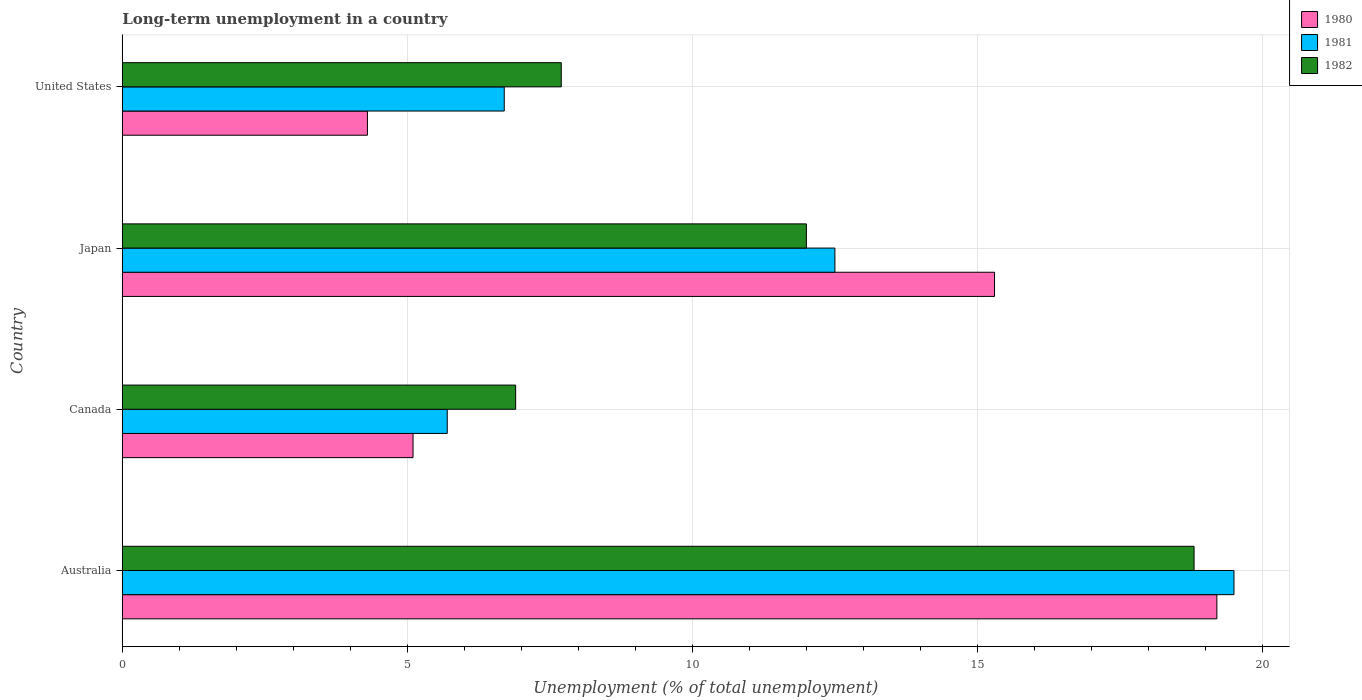Are the number of bars per tick equal to the number of legend labels?
Your answer should be compact. Yes. Are the number of bars on each tick of the Y-axis equal?
Provide a short and direct response. Yes. How many bars are there on the 4th tick from the top?
Your answer should be very brief. 3. What is the label of the 4th group of bars from the top?
Give a very brief answer. Australia. What is the percentage of long-term unemployed population in 1981 in United States?
Offer a very short reply. 6.7. Across all countries, what is the maximum percentage of long-term unemployed population in 1981?
Ensure brevity in your answer.  19.5. Across all countries, what is the minimum percentage of long-term unemployed population in 1982?
Your response must be concise. 6.9. In which country was the percentage of long-term unemployed population in 1981 maximum?
Your answer should be compact. Australia. What is the total percentage of long-term unemployed population in 1981 in the graph?
Make the answer very short. 44.4. What is the difference between the percentage of long-term unemployed population in 1982 in Canada and that in United States?
Provide a short and direct response. -0.8. What is the difference between the percentage of long-term unemployed population in 1981 in United States and the percentage of long-term unemployed population in 1982 in Australia?
Provide a succinct answer. -12.1. What is the average percentage of long-term unemployed population in 1981 per country?
Make the answer very short. 11.1. What is the difference between the percentage of long-term unemployed population in 1980 and percentage of long-term unemployed population in 1981 in Japan?
Your answer should be very brief. 2.8. In how many countries, is the percentage of long-term unemployed population in 1982 greater than 12 %?
Your answer should be compact. 1. What is the ratio of the percentage of long-term unemployed population in 1982 in Canada to that in Japan?
Your answer should be compact. 0.58. What is the difference between the highest and the lowest percentage of long-term unemployed population in 1982?
Provide a short and direct response. 11.9. In how many countries, is the percentage of long-term unemployed population in 1981 greater than the average percentage of long-term unemployed population in 1981 taken over all countries?
Ensure brevity in your answer.  2. Is the sum of the percentage of long-term unemployed population in 1982 in Australia and United States greater than the maximum percentage of long-term unemployed population in 1980 across all countries?
Your response must be concise. Yes. What does the 1st bar from the top in Japan represents?
Your answer should be compact. 1982. How many bars are there?
Provide a succinct answer. 12. How many countries are there in the graph?
Provide a succinct answer. 4. What is the difference between two consecutive major ticks on the X-axis?
Make the answer very short. 5. Does the graph contain grids?
Your answer should be compact. Yes. Where does the legend appear in the graph?
Offer a very short reply. Top right. How many legend labels are there?
Your answer should be very brief. 3. How are the legend labels stacked?
Offer a terse response. Vertical. What is the title of the graph?
Your answer should be compact. Long-term unemployment in a country. What is the label or title of the X-axis?
Keep it short and to the point. Unemployment (% of total unemployment). What is the Unemployment (% of total unemployment) of 1980 in Australia?
Ensure brevity in your answer.  19.2. What is the Unemployment (% of total unemployment) of 1982 in Australia?
Give a very brief answer. 18.8. What is the Unemployment (% of total unemployment) of 1980 in Canada?
Your answer should be compact. 5.1. What is the Unemployment (% of total unemployment) in 1981 in Canada?
Keep it short and to the point. 5.7. What is the Unemployment (% of total unemployment) of 1982 in Canada?
Offer a terse response. 6.9. What is the Unemployment (% of total unemployment) of 1980 in Japan?
Ensure brevity in your answer.  15.3. What is the Unemployment (% of total unemployment) in 1982 in Japan?
Offer a terse response. 12. What is the Unemployment (% of total unemployment) of 1980 in United States?
Your response must be concise. 4.3. What is the Unemployment (% of total unemployment) of 1981 in United States?
Ensure brevity in your answer.  6.7. What is the Unemployment (% of total unemployment) in 1982 in United States?
Offer a terse response. 7.7. Across all countries, what is the maximum Unemployment (% of total unemployment) of 1980?
Provide a succinct answer. 19.2. Across all countries, what is the maximum Unemployment (% of total unemployment) of 1982?
Offer a terse response. 18.8. Across all countries, what is the minimum Unemployment (% of total unemployment) in 1980?
Offer a very short reply. 4.3. Across all countries, what is the minimum Unemployment (% of total unemployment) of 1981?
Offer a very short reply. 5.7. Across all countries, what is the minimum Unemployment (% of total unemployment) in 1982?
Your answer should be very brief. 6.9. What is the total Unemployment (% of total unemployment) in 1980 in the graph?
Give a very brief answer. 43.9. What is the total Unemployment (% of total unemployment) of 1981 in the graph?
Ensure brevity in your answer.  44.4. What is the total Unemployment (% of total unemployment) of 1982 in the graph?
Your answer should be very brief. 45.4. What is the difference between the Unemployment (% of total unemployment) of 1981 in Australia and that in Canada?
Give a very brief answer. 13.8. What is the difference between the Unemployment (% of total unemployment) of 1982 in Australia and that in Canada?
Offer a very short reply. 11.9. What is the difference between the Unemployment (% of total unemployment) in 1981 in Australia and that in Japan?
Give a very brief answer. 7. What is the difference between the Unemployment (% of total unemployment) of 1982 in Australia and that in Japan?
Your answer should be very brief. 6.8. What is the difference between the Unemployment (% of total unemployment) of 1981 in Australia and that in United States?
Offer a terse response. 12.8. What is the difference between the Unemployment (% of total unemployment) in 1981 in Canada and that in Japan?
Ensure brevity in your answer.  -6.8. What is the difference between the Unemployment (% of total unemployment) in 1982 in Canada and that in United States?
Make the answer very short. -0.8. What is the difference between the Unemployment (% of total unemployment) in 1980 in Japan and that in United States?
Provide a succinct answer. 11. What is the difference between the Unemployment (% of total unemployment) in 1981 in Japan and that in United States?
Provide a succinct answer. 5.8. What is the difference between the Unemployment (% of total unemployment) of 1982 in Japan and that in United States?
Provide a short and direct response. 4.3. What is the difference between the Unemployment (% of total unemployment) of 1980 in Australia and the Unemployment (% of total unemployment) of 1982 in Canada?
Your response must be concise. 12.3. What is the difference between the Unemployment (% of total unemployment) of 1981 in Australia and the Unemployment (% of total unemployment) of 1982 in United States?
Keep it short and to the point. 11.8. What is the difference between the Unemployment (% of total unemployment) in 1981 in Canada and the Unemployment (% of total unemployment) in 1982 in Japan?
Offer a terse response. -6.3. What is the difference between the Unemployment (% of total unemployment) in 1980 in Canada and the Unemployment (% of total unemployment) in 1982 in United States?
Ensure brevity in your answer.  -2.6. What is the difference between the Unemployment (% of total unemployment) in 1980 in Japan and the Unemployment (% of total unemployment) in 1982 in United States?
Your answer should be compact. 7.6. What is the average Unemployment (% of total unemployment) in 1980 per country?
Your answer should be compact. 10.97. What is the average Unemployment (% of total unemployment) of 1981 per country?
Provide a succinct answer. 11.1. What is the average Unemployment (% of total unemployment) in 1982 per country?
Give a very brief answer. 11.35. What is the difference between the Unemployment (% of total unemployment) in 1980 and Unemployment (% of total unemployment) in 1982 in Australia?
Your response must be concise. 0.4. What is the difference between the Unemployment (% of total unemployment) of 1981 and Unemployment (% of total unemployment) of 1982 in Australia?
Your answer should be very brief. 0.7. What is the difference between the Unemployment (% of total unemployment) in 1980 and Unemployment (% of total unemployment) in 1981 in Canada?
Ensure brevity in your answer.  -0.6. What is the difference between the Unemployment (% of total unemployment) in 1980 and Unemployment (% of total unemployment) in 1982 in Canada?
Ensure brevity in your answer.  -1.8. What is the difference between the Unemployment (% of total unemployment) in 1981 and Unemployment (% of total unemployment) in 1982 in Canada?
Offer a terse response. -1.2. What is the ratio of the Unemployment (% of total unemployment) in 1980 in Australia to that in Canada?
Keep it short and to the point. 3.76. What is the ratio of the Unemployment (% of total unemployment) of 1981 in Australia to that in Canada?
Make the answer very short. 3.42. What is the ratio of the Unemployment (% of total unemployment) in 1982 in Australia to that in Canada?
Provide a succinct answer. 2.72. What is the ratio of the Unemployment (% of total unemployment) of 1980 in Australia to that in Japan?
Provide a short and direct response. 1.25. What is the ratio of the Unemployment (% of total unemployment) of 1981 in Australia to that in Japan?
Your response must be concise. 1.56. What is the ratio of the Unemployment (% of total unemployment) in 1982 in Australia to that in Japan?
Your response must be concise. 1.57. What is the ratio of the Unemployment (% of total unemployment) of 1980 in Australia to that in United States?
Your answer should be compact. 4.47. What is the ratio of the Unemployment (% of total unemployment) in 1981 in Australia to that in United States?
Provide a short and direct response. 2.91. What is the ratio of the Unemployment (% of total unemployment) of 1982 in Australia to that in United States?
Keep it short and to the point. 2.44. What is the ratio of the Unemployment (% of total unemployment) in 1980 in Canada to that in Japan?
Ensure brevity in your answer.  0.33. What is the ratio of the Unemployment (% of total unemployment) of 1981 in Canada to that in Japan?
Give a very brief answer. 0.46. What is the ratio of the Unemployment (% of total unemployment) of 1982 in Canada to that in Japan?
Offer a very short reply. 0.57. What is the ratio of the Unemployment (% of total unemployment) of 1980 in Canada to that in United States?
Provide a short and direct response. 1.19. What is the ratio of the Unemployment (% of total unemployment) in 1981 in Canada to that in United States?
Provide a succinct answer. 0.85. What is the ratio of the Unemployment (% of total unemployment) in 1982 in Canada to that in United States?
Make the answer very short. 0.9. What is the ratio of the Unemployment (% of total unemployment) of 1980 in Japan to that in United States?
Offer a terse response. 3.56. What is the ratio of the Unemployment (% of total unemployment) of 1981 in Japan to that in United States?
Provide a short and direct response. 1.87. What is the ratio of the Unemployment (% of total unemployment) in 1982 in Japan to that in United States?
Make the answer very short. 1.56. 